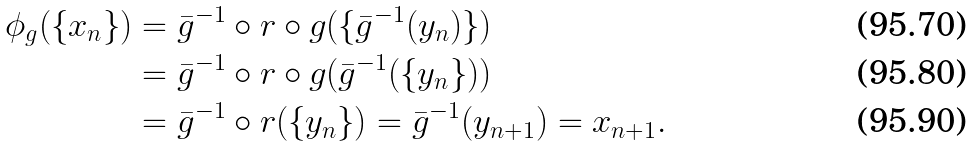<formula> <loc_0><loc_0><loc_500><loc_500>\phi _ { g } ( \{ x _ { n } \} ) & = \bar { g } ^ { - 1 } \circ r \circ g ( \{ \bar { g } ^ { - 1 } ( y _ { n } ) \} ) \\ & = \bar { g } ^ { - 1 } \circ r \circ g ( \bar { g } ^ { - 1 } ( \{ y _ { n } \} ) ) \\ & = \bar { g } ^ { - 1 } \circ r ( \{ y _ { n } \} ) = \bar { g } ^ { - 1 } ( y _ { n + 1 } ) = x _ { n + 1 } .</formula> 